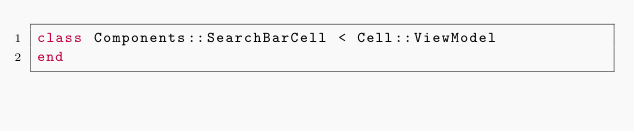Convert code to text. <code><loc_0><loc_0><loc_500><loc_500><_Ruby_>class Components::SearchBarCell < Cell::ViewModel
end
</code> 